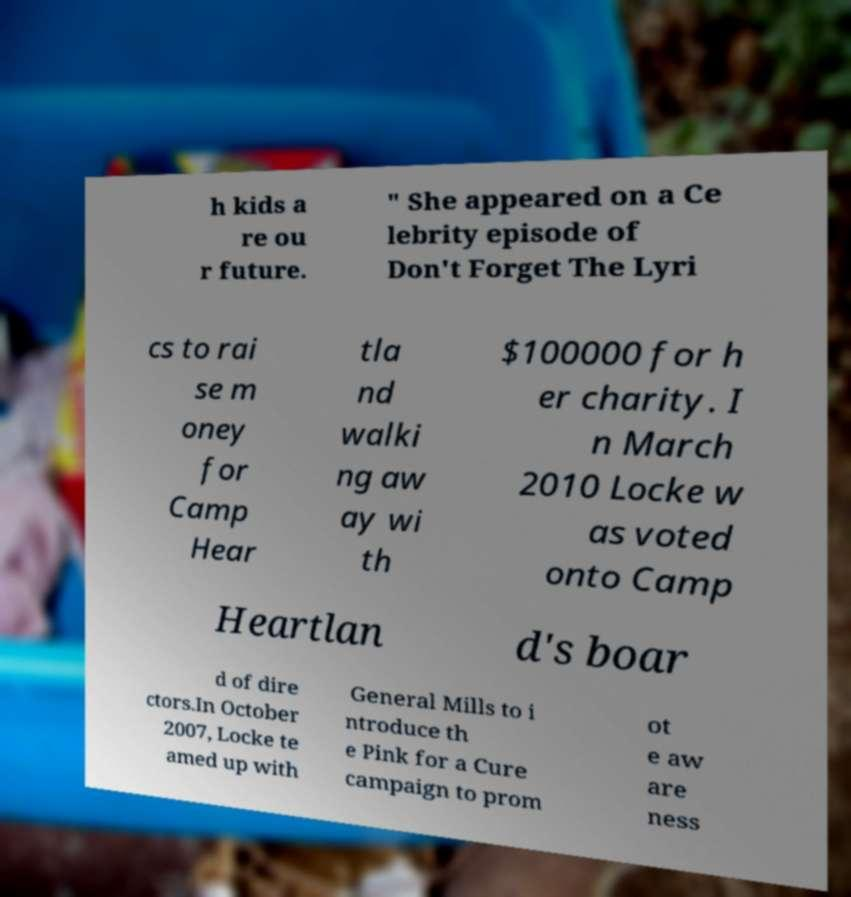Please read and relay the text visible in this image. What does it say? h kids a re ou r future. " She appeared on a Ce lebrity episode of Don't Forget The Lyri cs to rai se m oney for Camp Hear tla nd walki ng aw ay wi th $100000 for h er charity. I n March 2010 Locke w as voted onto Camp Heartlan d's boar d of dire ctors.In October 2007, Locke te amed up with General Mills to i ntroduce th e Pink for a Cure campaign to prom ot e aw are ness 